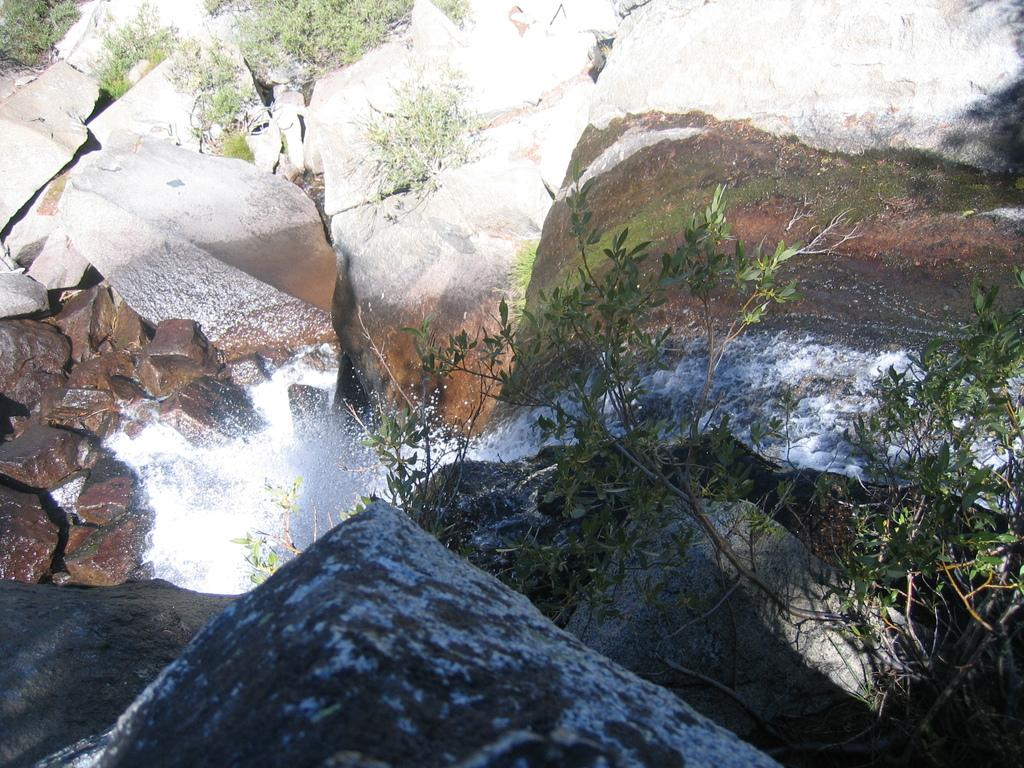What is the main feature of the image? The main feature of the image is a water flow. What else can be seen in the image besides the water flow? There are rocks, plants, and algae in the image. What type of lead is being used by the queen in the image? There is no queen or lead present in the image; it features a water flow with rocks, plants, and algae. Is there a bathtub visible in the image? There is no bathtub present in the image; it features a water flow with rocks, plants, and algae. 